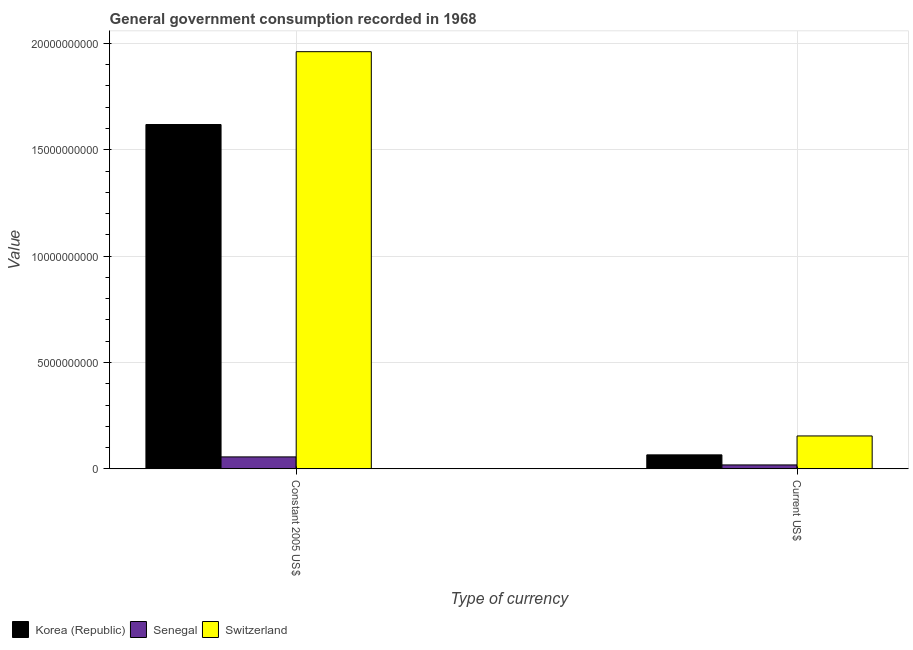How many groups of bars are there?
Your answer should be very brief. 2. Are the number of bars per tick equal to the number of legend labels?
Your answer should be compact. Yes. What is the label of the 2nd group of bars from the left?
Your response must be concise. Current US$. What is the value consumed in constant 2005 us$ in Switzerland?
Keep it short and to the point. 1.96e+1. Across all countries, what is the maximum value consumed in constant 2005 us$?
Your answer should be compact. 1.96e+1. Across all countries, what is the minimum value consumed in constant 2005 us$?
Make the answer very short. 5.61e+08. In which country was the value consumed in constant 2005 us$ maximum?
Provide a succinct answer. Switzerland. In which country was the value consumed in constant 2005 us$ minimum?
Provide a succinct answer. Senegal. What is the total value consumed in current us$ in the graph?
Your response must be concise. 2.39e+09. What is the difference between the value consumed in current us$ in Senegal and that in Switzerland?
Make the answer very short. -1.36e+09. What is the difference between the value consumed in constant 2005 us$ in Senegal and the value consumed in current us$ in Korea (Republic)?
Provide a short and direct response. -9.61e+07. What is the average value consumed in current us$ per country?
Offer a very short reply. 7.96e+08. What is the difference between the value consumed in current us$ and value consumed in constant 2005 us$ in Korea (Republic)?
Provide a short and direct response. -1.55e+1. What is the ratio of the value consumed in current us$ in Switzerland to that in Senegal?
Your answer should be very brief. 8.39. Is the value consumed in constant 2005 us$ in Senegal less than that in Korea (Republic)?
Make the answer very short. Yes. In how many countries, is the value consumed in constant 2005 us$ greater than the average value consumed in constant 2005 us$ taken over all countries?
Your answer should be compact. 2. What does the 2nd bar from the left in Constant 2005 US$ represents?
Provide a short and direct response. Senegal. What does the 2nd bar from the right in Constant 2005 US$ represents?
Make the answer very short. Senegal. How many bars are there?
Give a very brief answer. 6. Does the graph contain any zero values?
Your answer should be very brief. No. How many legend labels are there?
Provide a short and direct response. 3. How are the legend labels stacked?
Provide a short and direct response. Horizontal. What is the title of the graph?
Keep it short and to the point. General government consumption recorded in 1968. What is the label or title of the X-axis?
Keep it short and to the point. Type of currency. What is the label or title of the Y-axis?
Keep it short and to the point. Value. What is the Value in Korea (Republic) in Constant 2005 US$?
Provide a short and direct response. 1.62e+1. What is the Value of Senegal in Constant 2005 US$?
Your response must be concise. 5.61e+08. What is the Value in Switzerland in Constant 2005 US$?
Ensure brevity in your answer.  1.96e+1. What is the Value in Korea (Republic) in Current US$?
Your answer should be compact. 6.57e+08. What is the Value in Senegal in Current US$?
Offer a terse response. 1.84e+08. What is the Value in Switzerland in Current US$?
Offer a terse response. 1.55e+09. Across all Type of currency, what is the maximum Value in Korea (Republic)?
Your answer should be very brief. 1.62e+1. Across all Type of currency, what is the maximum Value in Senegal?
Make the answer very short. 5.61e+08. Across all Type of currency, what is the maximum Value in Switzerland?
Provide a short and direct response. 1.96e+1. Across all Type of currency, what is the minimum Value in Korea (Republic)?
Your response must be concise. 6.57e+08. Across all Type of currency, what is the minimum Value of Senegal?
Ensure brevity in your answer.  1.84e+08. Across all Type of currency, what is the minimum Value of Switzerland?
Keep it short and to the point. 1.55e+09. What is the total Value in Korea (Republic) in the graph?
Provide a succinct answer. 1.68e+1. What is the total Value of Senegal in the graph?
Your response must be concise. 7.46e+08. What is the total Value in Switzerland in the graph?
Make the answer very short. 2.12e+1. What is the difference between the Value of Korea (Republic) in Constant 2005 US$ and that in Current US$?
Your response must be concise. 1.55e+1. What is the difference between the Value in Senegal in Constant 2005 US$ and that in Current US$?
Offer a terse response. 3.77e+08. What is the difference between the Value of Switzerland in Constant 2005 US$ and that in Current US$?
Your answer should be compact. 1.81e+1. What is the difference between the Value of Korea (Republic) in Constant 2005 US$ and the Value of Senegal in Current US$?
Offer a terse response. 1.60e+1. What is the difference between the Value in Korea (Republic) in Constant 2005 US$ and the Value in Switzerland in Current US$?
Your answer should be compact. 1.46e+1. What is the difference between the Value in Senegal in Constant 2005 US$ and the Value in Switzerland in Current US$?
Your response must be concise. -9.85e+08. What is the average Value in Korea (Republic) per Type of currency?
Your answer should be compact. 8.42e+09. What is the average Value of Senegal per Type of currency?
Your response must be concise. 3.73e+08. What is the average Value in Switzerland per Type of currency?
Make the answer very short. 1.06e+1. What is the difference between the Value of Korea (Republic) and Value of Senegal in Constant 2005 US$?
Provide a short and direct response. 1.56e+1. What is the difference between the Value of Korea (Republic) and Value of Switzerland in Constant 2005 US$?
Give a very brief answer. -3.42e+09. What is the difference between the Value of Senegal and Value of Switzerland in Constant 2005 US$?
Offer a terse response. -1.90e+1. What is the difference between the Value of Korea (Republic) and Value of Senegal in Current US$?
Your answer should be compact. 4.73e+08. What is the difference between the Value of Korea (Republic) and Value of Switzerland in Current US$?
Keep it short and to the point. -8.89e+08. What is the difference between the Value of Senegal and Value of Switzerland in Current US$?
Offer a terse response. -1.36e+09. What is the ratio of the Value of Korea (Republic) in Constant 2005 US$ to that in Current US$?
Give a very brief answer. 24.62. What is the ratio of the Value in Senegal in Constant 2005 US$ to that in Current US$?
Your answer should be very brief. 3.04. What is the ratio of the Value in Switzerland in Constant 2005 US$ to that in Current US$?
Give a very brief answer. 12.68. What is the difference between the highest and the second highest Value of Korea (Republic)?
Make the answer very short. 1.55e+1. What is the difference between the highest and the second highest Value in Senegal?
Offer a terse response. 3.77e+08. What is the difference between the highest and the second highest Value in Switzerland?
Give a very brief answer. 1.81e+1. What is the difference between the highest and the lowest Value of Korea (Republic)?
Offer a very short reply. 1.55e+1. What is the difference between the highest and the lowest Value of Senegal?
Your answer should be very brief. 3.77e+08. What is the difference between the highest and the lowest Value in Switzerland?
Offer a terse response. 1.81e+1. 